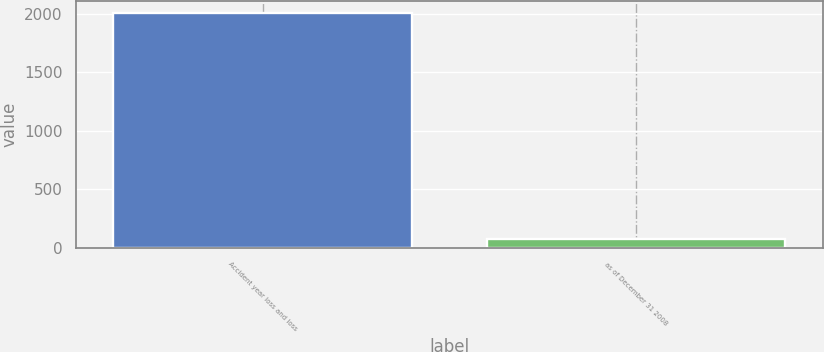Convert chart. <chart><loc_0><loc_0><loc_500><loc_500><bar_chart><fcel>Accident year loss and loss<fcel>as of December 31 2008<nl><fcel>2008<fcel>74.3<nl></chart> 